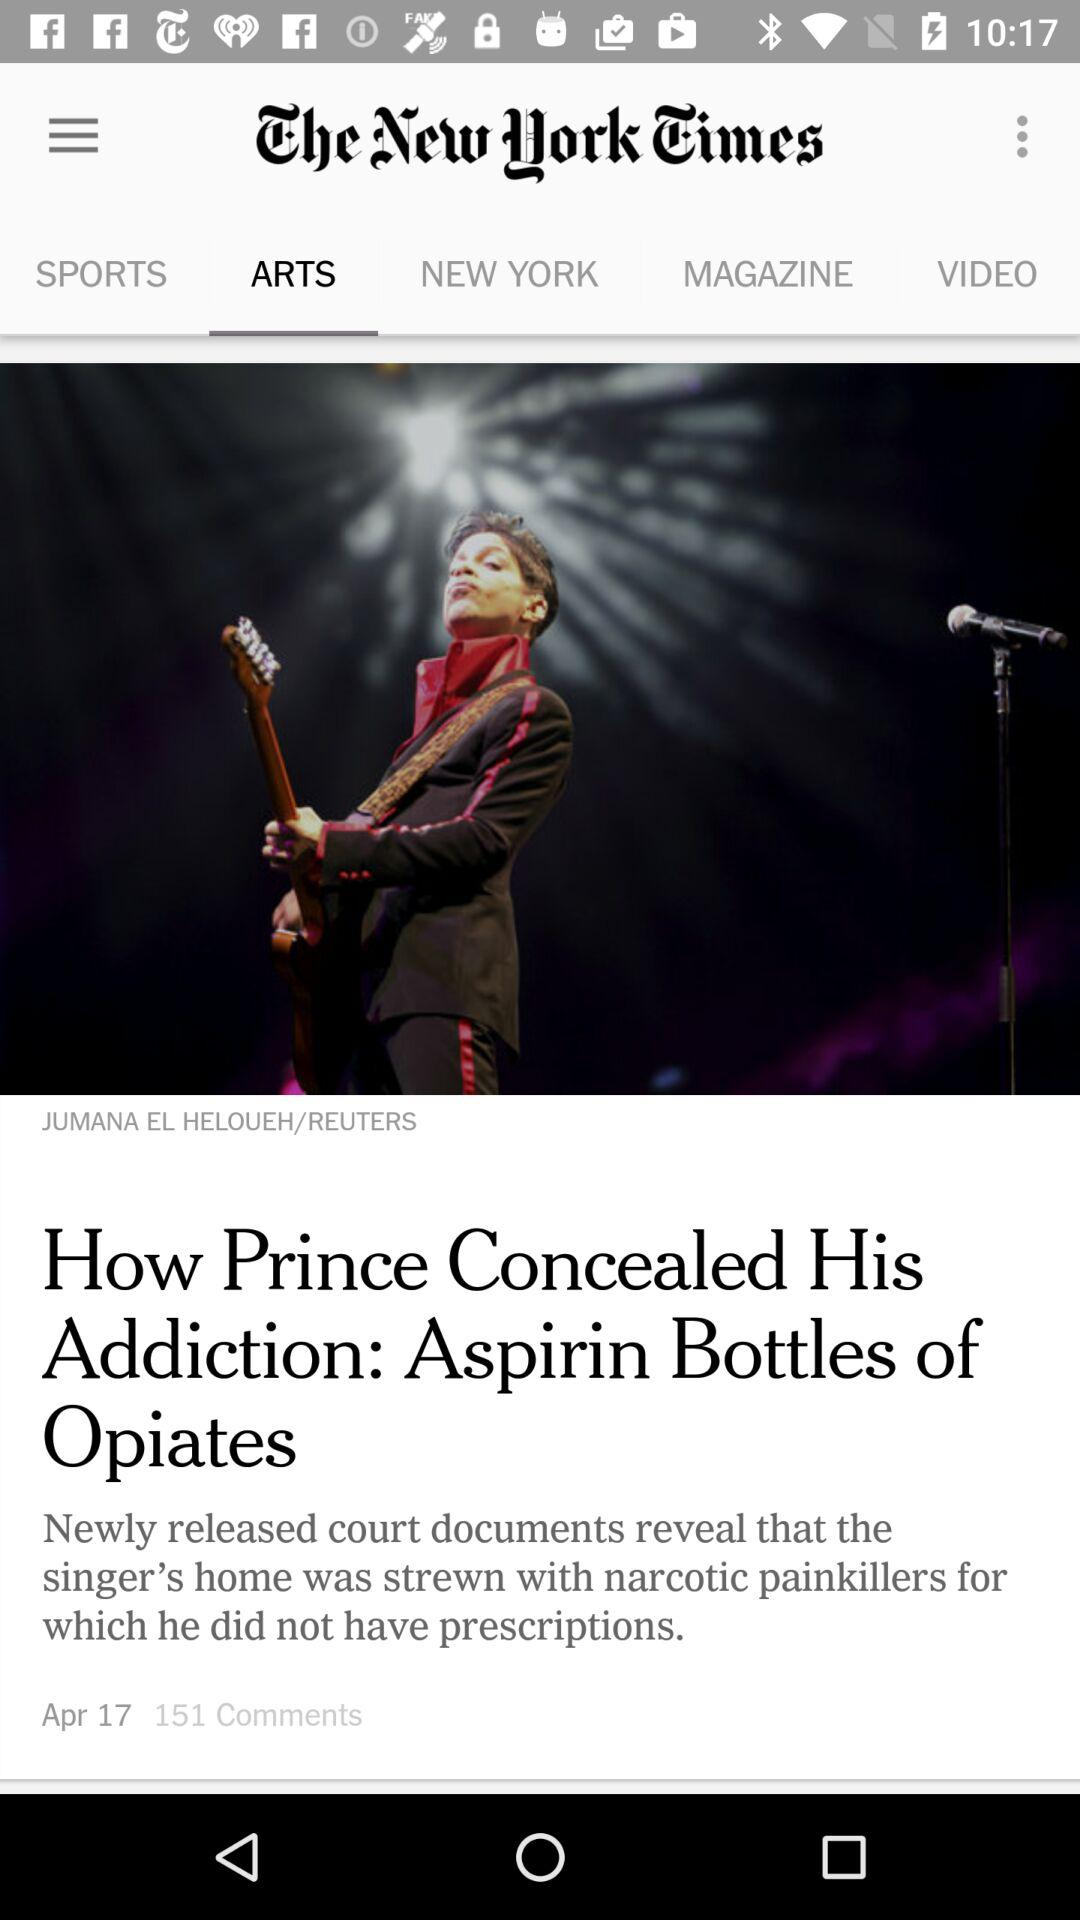How many comments did "How Prince Concealed His Addiction" get? "How Prince Concealed His Addiction" got 151 comments. 